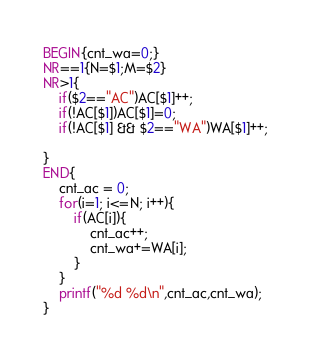<code> <loc_0><loc_0><loc_500><loc_500><_Awk_>BEGIN{cnt_wa=0;}
NR==1{N=$1;M=$2}
NR>1{
    if($2=="AC")AC[$1]++;
    if(!AC[$1])AC[$1]=0;
    if(!AC[$1] && $2=="WA")WA[$1]++;
    
}
END{
	cnt_ac = 0;
	for(i=1; i<=N; i++){
		if(AC[i]){
        	cnt_ac++;
            cnt_wa+=WA[i];
        }
    }
    printf("%d %d\n",cnt_ac,cnt_wa);
}
</code> 